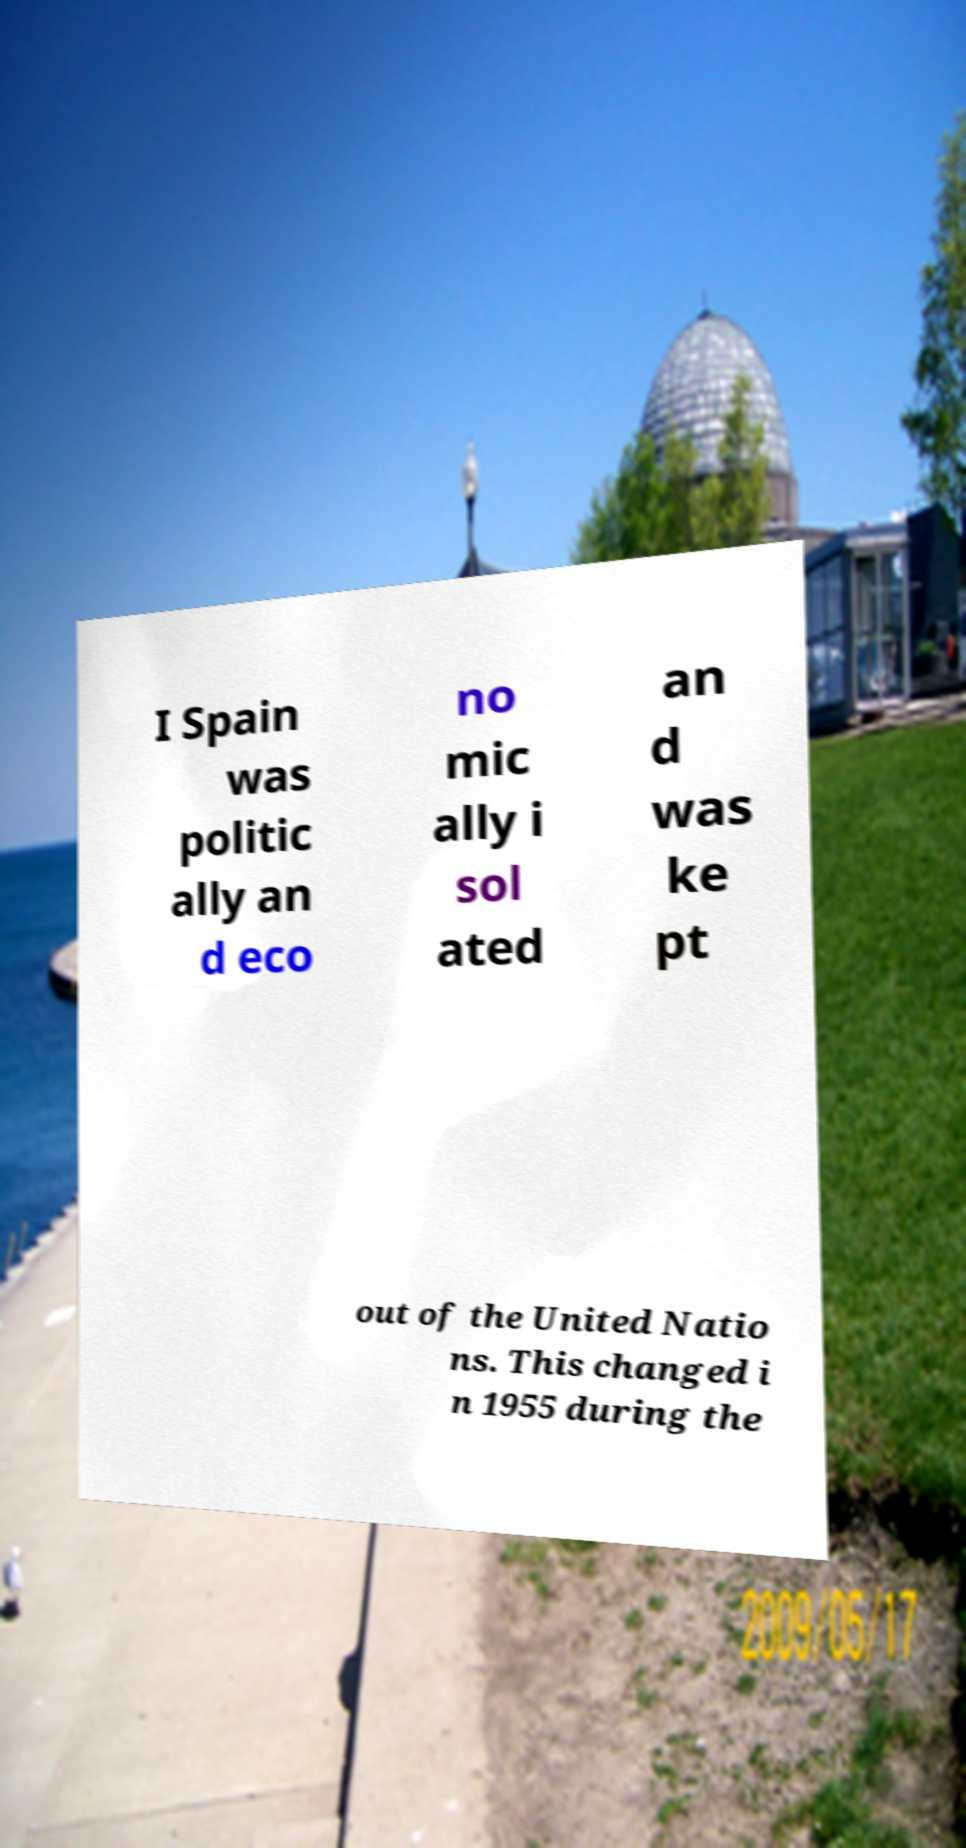For documentation purposes, I need the text within this image transcribed. Could you provide that? I Spain was politic ally an d eco no mic ally i sol ated an d was ke pt out of the United Natio ns. This changed i n 1955 during the 